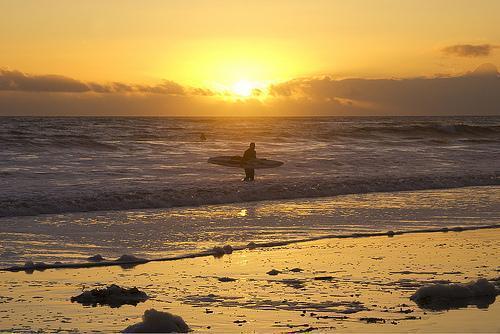How many people are in the water?
Give a very brief answer. 1. 